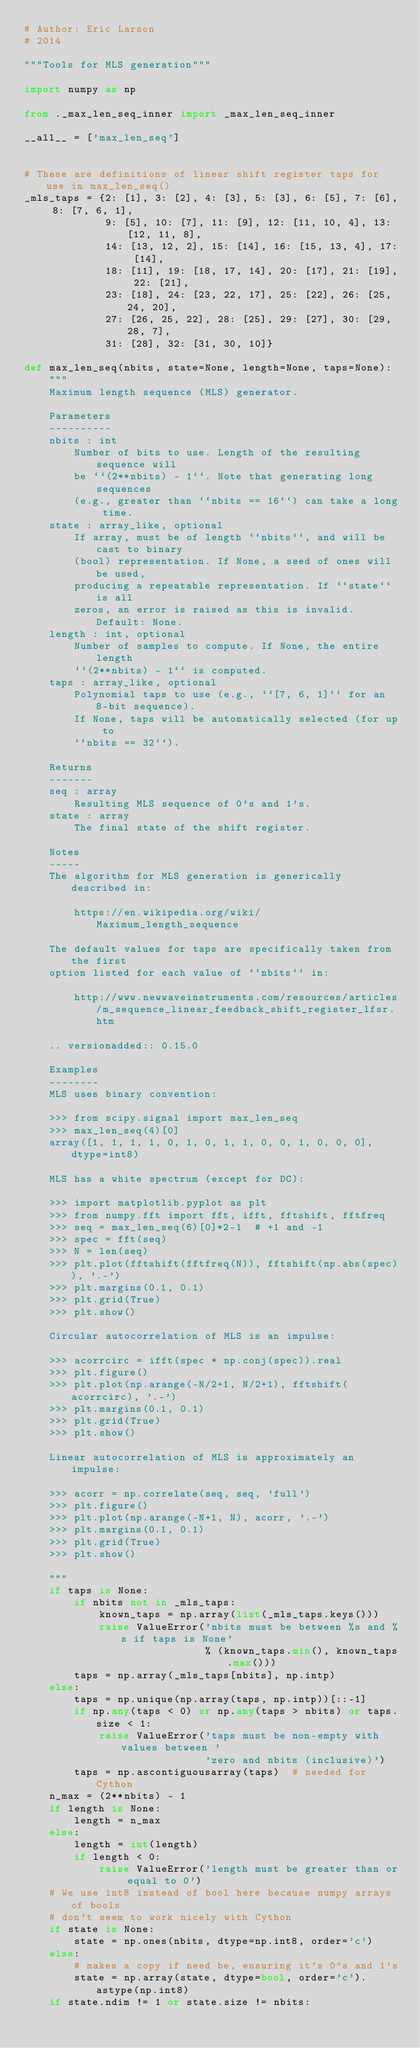<code> <loc_0><loc_0><loc_500><loc_500><_Python_># Author: Eric Larson
# 2014

"""Tools for MLS generation"""

import numpy as np

from ._max_len_seq_inner import _max_len_seq_inner

__all__ = ['max_len_seq']


# These are definitions of linear shift register taps for use in max_len_seq()
_mls_taps = {2: [1], 3: [2], 4: [3], 5: [3], 6: [5], 7: [6], 8: [7, 6, 1],
             9: [5], 10: [7], 11: [9], 12: [11, 10, 4], 13: [12, 11, 8],
             14: [13, 12, 2], 15: [14], 16: [15, 13, 4], 17: [14],
             18: [11], 19: [18, 17, 14], 20: [17], 21: [19], 22: [21],
             23: [18], 24: [23, 22, 17], 25: [22], 26: [25, 24, 20],
             27: [26, 25, 22], 28: [25], 29: [27], 30: [29, 28, 7],
             31: [28], 32: [31, 30, 10]}

def max_len_seq(nbits, state=None, length=None, taps=None):
    """
    Maximum length sequence (MLS) generator.

    Parameters
    ----------
    nbits : int
        Number of bits to use. Length of the resulting sequence will
        be ``(2**nbits) - 1``. Note that generating long sequences
        (e.g., greater than ``nbits == 16``) can take a long time.
    state : array_like, optional
        If array, must be of length ``nbits``, and will be cast to binary
        (bool) representation. If None, a seed of ones will be used,
        producing a repeatable representation. If ``state`` is all
        zeros, an error is raised as this is invalid. Default: None.
    length : int, optional
        Number of samples to compute. If None, the entire length
        ``(2**nbits) - 1`` is computed.
    taps : array_like, optional
        Polynomial taps to use (e.g., ``[7, 6, 1]`` for an 8-bit sequence).
        If None, taps will be automatically selected (for up to
        ``nbits == 32``).

    Returns
    -------
    seq : array
        Resulting MLS sequence of 0's and 1's.
    state : array
        The final state of the shift register.

    Notes
    -----
    The algorithm for MLS generation is generically described in:

        https://en.wikipedia.org/wiki/Maximum_length_sequence

    The default values for taps are specifically taken from the first
    option listed for each value of ``nbits`` in:

        http://www.newwaveinstruments.com/resources/articles/m_sequence_linear_feedback_shift_register_lfsr.htm

    .. versionadded:: 0.15.0

    Examples
    --------
    MLS uses binary convention:

    >>> from scipy.signal import max_len_seq
    >>> max_len_seq(4)[0]
    array([1, 1, 1, 1, 0, 1, 0, 1, 1, 0, 0, 1, 0, 0, 0], dtype=int8)

    MLS has a white spectrum (except for DC):

    >>> import matplotlib.pyplot as plt
    >>> from numpy.fft import fft, ifft, fftshift, fftfreq
    >>> seq = max_len_seq(6)[0]*2-1  # +1 and -1
    >>> spec = fft(seq)
    >>> N = len(seq)
    >>> plt.plot(fftshift(fftfreq(N)), fftshift(np.abs(spec)), '.-')
    >>> plt.margins(0.1, 0.1)
    >>> plt.grid(True)
    >>> plt.show()

    Circular autocorrelation of MLS is an impulse:

    >>> acorrcirc = ifft(spec * np.conj(spec)).real
    >>> plt.figure()
    >>> plt.plot(np.arange(-N/2+1, N/2+1), fftshift(acorrcirc), '.-')
    >>> plt.margins(0.1, 0.1)
    >>> plt.grid(True)
    >>> plt.show()

    Linear autocorrelation of MLS is approximately an impulse:

    >>> acorr = np.correlate(seq, seq, 'full')
    >>> plt.figure()
    >>> plt.plot(np.arange(-N+1, N), acorr, '.-')
    >>> plt.margins(0.1, 0.1)
    >>> plt.grid(True)
    >>> plt.show()

    """
    if taps is None:
        if nbits not in _mls_taps:
            known_taps = np.array(list(_mls_taps.keys()))
            raise ValueError('nbits must be between %s and %s if taps is None'
                             % (known_taps.min(), known_taps.max()))
        taps = np.array(_mls_taps[nbits], np.intp)
    else:
        taps = np.unique(np.array(taps, np.intp))[::-1]
        if np.any(taps < 0) or np.any(taps > nbits) or taps.size < 1:
            raise ValueError('taps must be non-empty with values between '
                             'zero and nbits (inclusive)')
        taps = np.ascontiguousarray(taps)  # needed for Cython
    n_max = (2**nbits) - 1
    if length is None:
        length = n_max
    else:
        length = int(length)
        if length < 0:
            raise ValueError('length must be greater than or equal to 0')
    # We use int8 instead of bool here because numpy arrays of bools
    # don't seem to work nicely with Cython
    if state is None:
        state = np.ones(nbits, dtype=np.int8, order='c')
    else:
        # makes a copy if need be, ensuring it's 0's and 1's
        state = np.array(state, dtype=bool, order='c').astype(np.int8)
    if state.ndim != 1 or state.size != nbits:</code> 